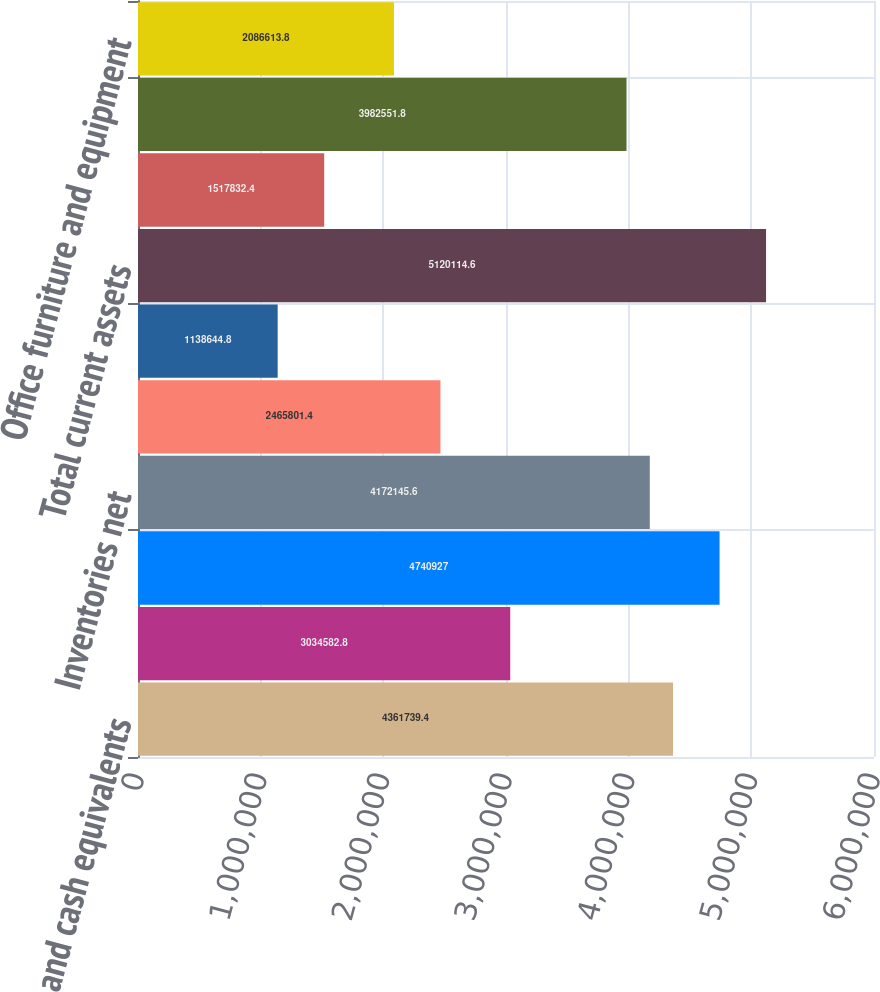Convert chart to OTSL. <chart><loc_0><loc_0><loc_500><loc_500><bar_chart><fcel>Cash and cash equivalents<fcel>Marketable securities ( Note<fcel>5340 in 2006 and 4226 in 2005<fcel>Inventories net<fcel>Deferred income taxes (Note 7)<fcel>Prepaid expenses and other<fcel>Total current assets<fcel>Land and improvements<fcel>Building and improvements<fcel>Office furniture and equipment<nl><fcel>4.36174e+06<fcel>3.03458e+06<fcel>4.74093e+06<fcel>4.17215e+06<fcel>2.4658e+06<fcel>1.13864e+06<fcel>5.12011e+06<fcel>1.51783e+06<fcel>3.98255e+06<fcel>2.08661e+06<nl></chart> 